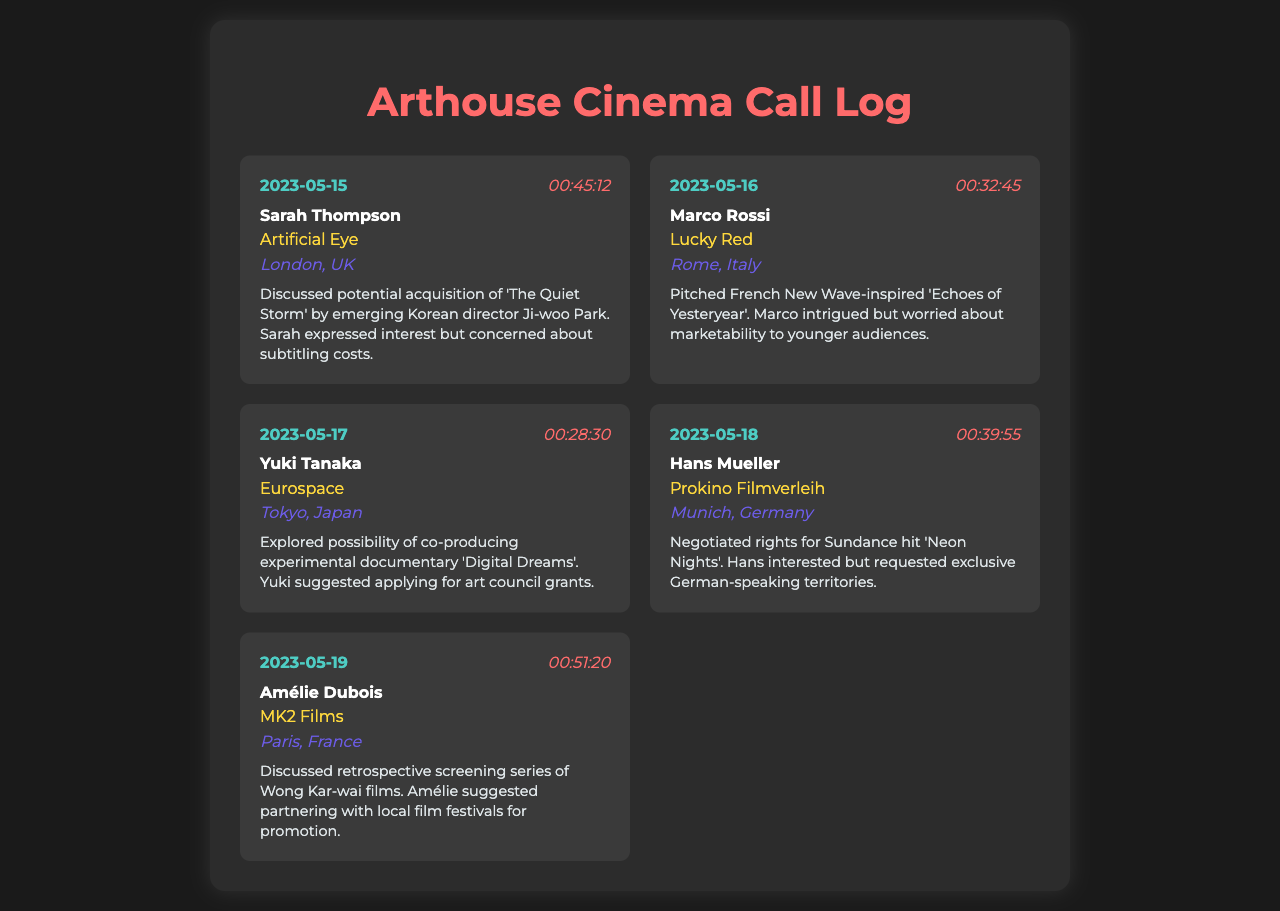What is the date of the call with Sarah Thompson? The date of the call with Sarah Thompson is listed as May 15, 2023.
Answer: May 15, 2023 Who was the contact for the call discussing 'Neon Nights'? The contact for the call discussing 'Neon Nights' was Hans Mueller.
Answer: Hans Mueller What is the primary concern of Marco Rossi regarding 'Echoes of Yesteryear'? Marco Rossi's primary concern is about the marketability to younger audiences.
Answer: Marketability to younger audiences Which film was discussed during the call with Amélie Dubois? The film discussed during the call with Amélie Dubois was Wong Kar-wai films for a retrospective screening series.
Answer: Wong Kar-wai films How long was the call with Yuki Tanaka? The duration of the call with Yuki Tanaka was 28 minutes and 30 seconds.
Answer: 00:28:30 What location is associated with the call to Artificial Eye? The location associated with the call to Artificial Eye is London, UK.
Answer: London, UK What did Yuki suggest for 'Digital Dreams'? Yuki suggested applying for art council grants.
Answer: Art council grants What was Hans interested in during the call about 'Neon Nights'? Hans was interested in negotiating rights for 'Neon Nights'.
Answer: Negotiating rights What is the focus of the call on May 19th? The focus of the call on May 19th was discussed with Amélie Dubois regarding Wong Kar-wai films.
Answer: Wong Kar-wai films 